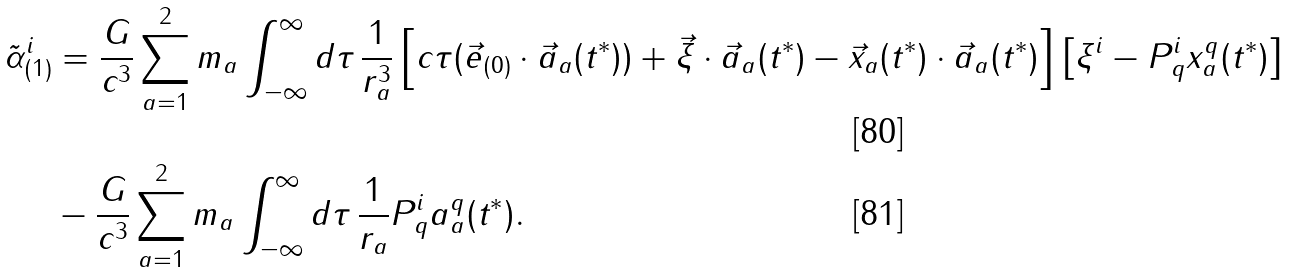<formula> <loc_0><loc_0><loc_500><loc_500>\tilde { \alpha } ^ { i } _ { ( 1 ) } & = \frac { G } { c ^ { 3 } } \sum _ { a = 1 } ^ { 2 } m _ { a } \int _ { - \infty } ^ { \infty } d \tau \, \frac { 1 } { r ^ { 3 } _ { a } } \left [ c \tau ( \vec { e } _ { ( 0 ) } \cdot \vec { a } _ { a } ( t ^ { \ast } ) ) + \vec { \xi } \cdot \vec { a } _ { a } ( t ^ { \ast } ) - \vec { x } _ { a } ( t ^ { \ast } ) \cdot \vec { a } _ { a } ( t ^ { \ast } ) \right ] \left [ \xi ^ { i } - P ^ { i } _ { q } x ^ { q } _ { a } ( t ^ { \ast } ) \right ] \\ & - \frac { G } { c ^ { 3 } } \sum _ { a = 1 } ^ { 2 } m _ { a } \int _ { - \infty } ^ { \infty } d \tau \, \frac { 1 } { r _ { a } } P ^ { i } _ { q } a ^ { q } _ { a } ( t ^ { \ast } ) .</formula> 